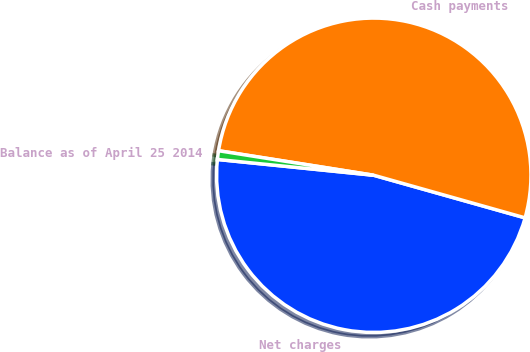Convert chart. <chart><loc_0><loc_0><loc_500><loc_500><pie_chart><fcel>Net charges<fcel>Cash payments<fcel>Balance as of April 25 2014<nl><fcel>47.24%<fcel>51.88%<fcel>0.89%<nl></chart> 